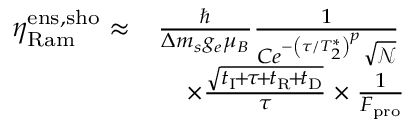<formula> <loc_0><loc_0><loc_500><loc_500>\begin{array} { r l } { \eta _ { R a m } ^ { e n s , s h o } \approx } & { \frac { } { \Delta m _ { s } g _ { e } \mu _ { B } } \frac { 1 } { C e ^ { - \left ( \tau / T _ { 2 } ^ { * } \right ) ^ { p } } \sqrt { \ m a t h s c r { N } } } } \\ & { \quad \times \frac { \sqrt { t _ { I } \, + \, \tau \, + \, t _ { R } \, + \, t _ { D } } } { \tau } \times \frac { 1 } { F _ { p r o } } } \end{array}</formula> 